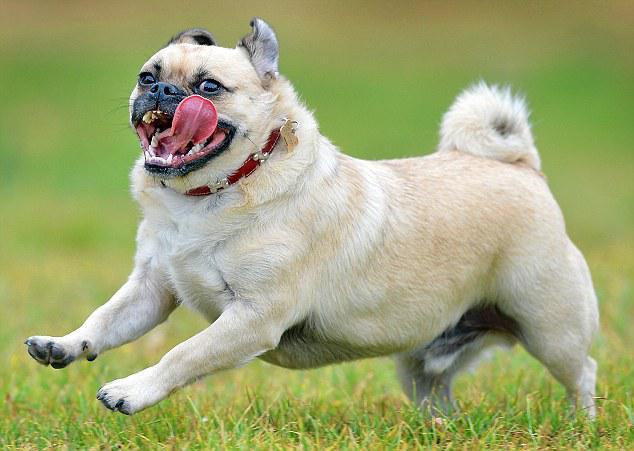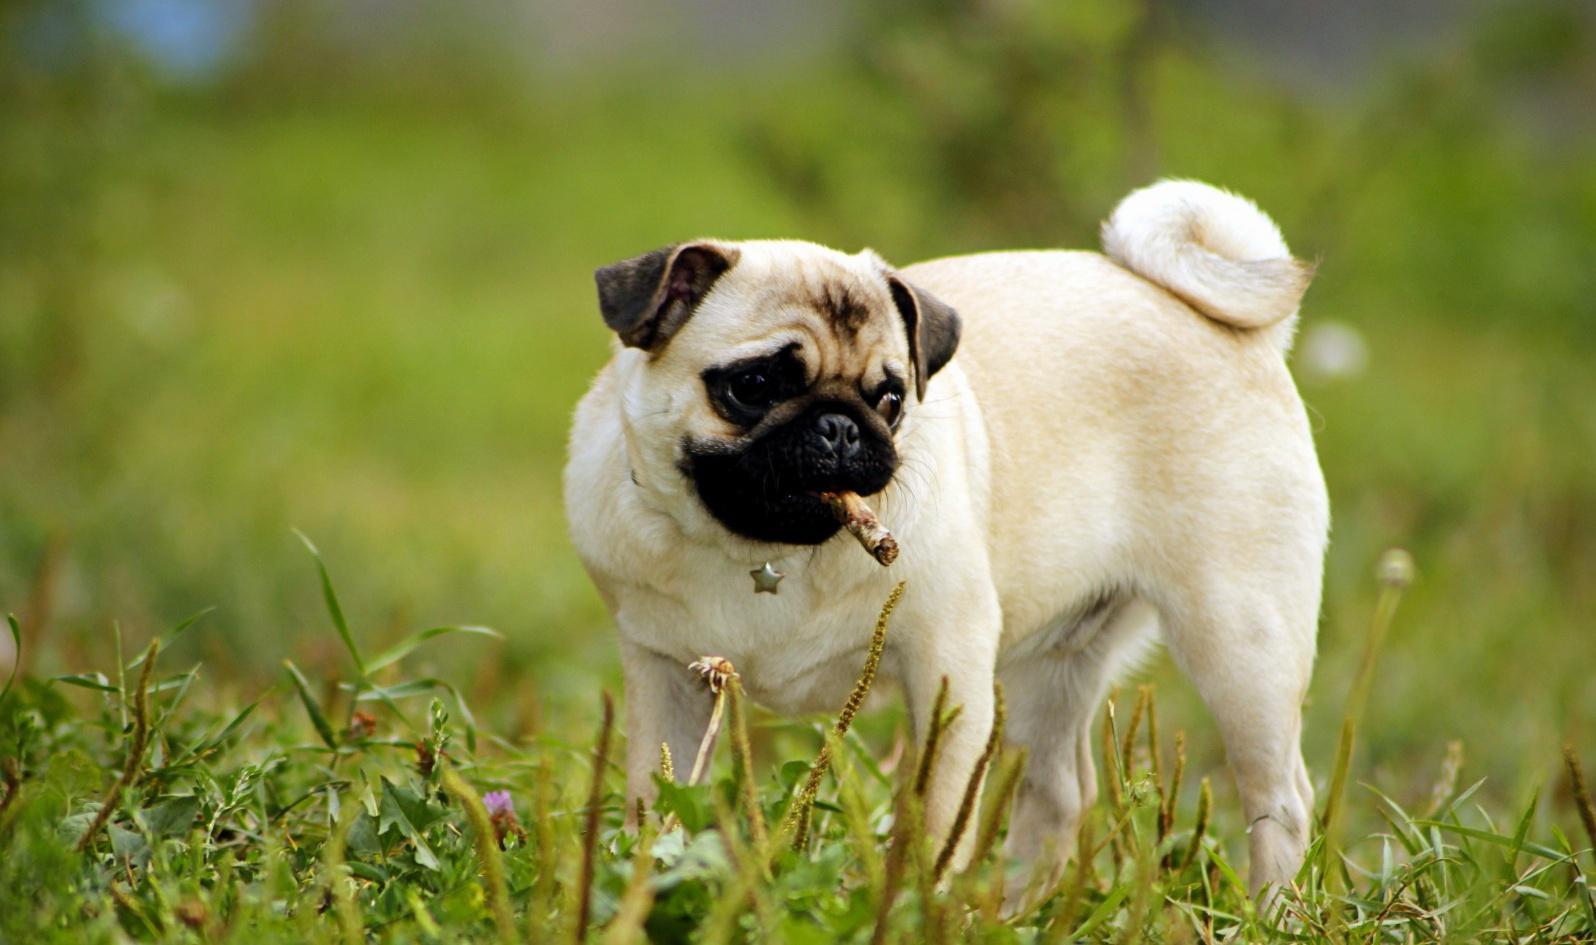The first image is the image on the left, the second image is the image on the right. For the images shown, is this caption "A small dark-faced dog has a stick in its mouth and is standing in a field." true? Answer yes or no. Yes. 